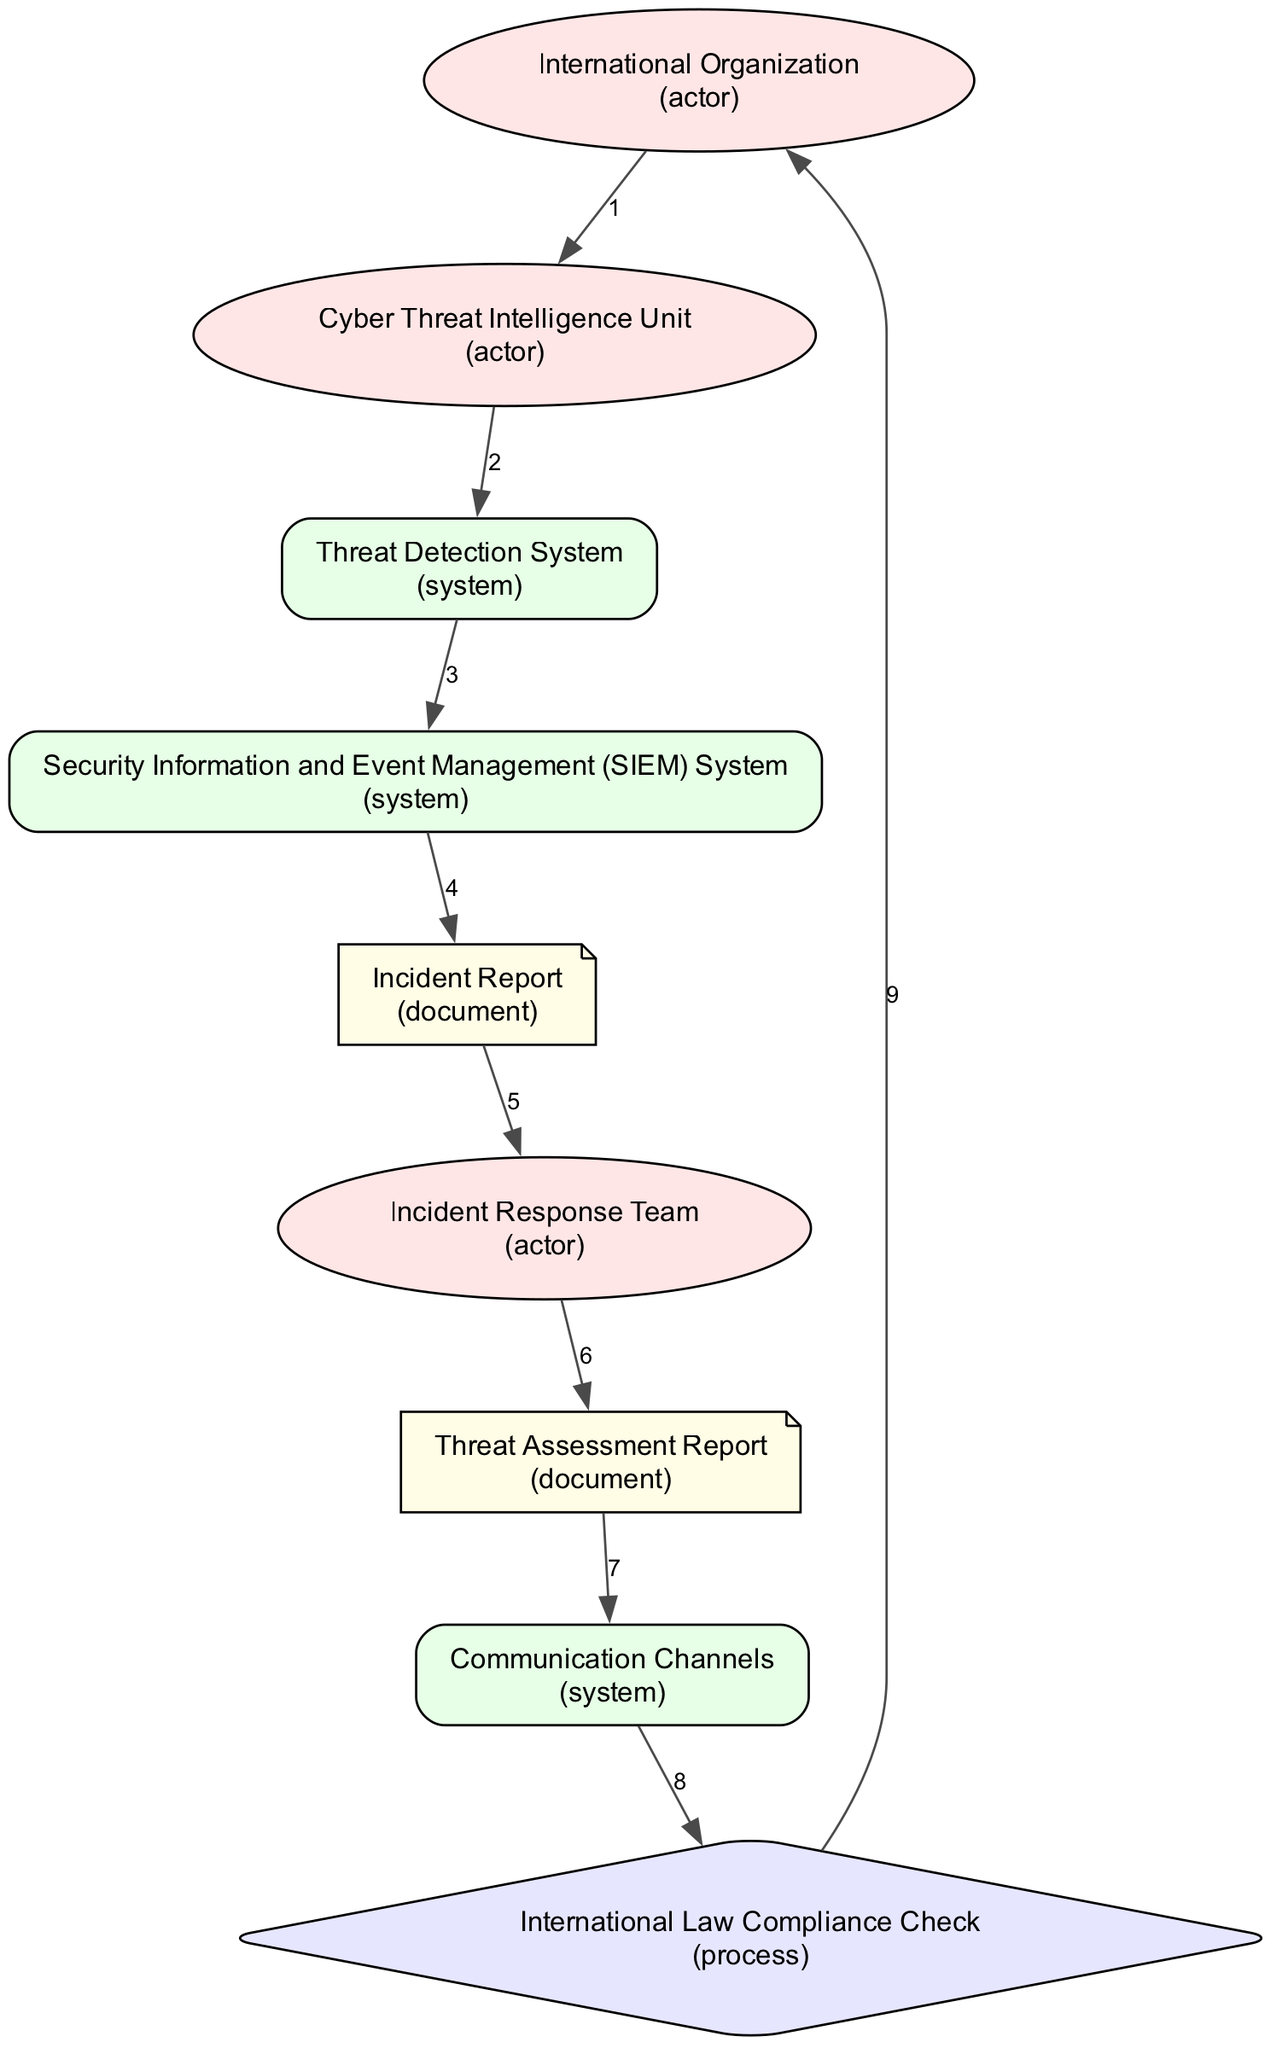What is the first actor in the sequence? The first actor listed in the sequence is "International Organization," which is the starting point for the response protocol in the diagram.
Answer: International Organization How many actors are involved in the diagram? There are three actors involved: "International Organization," "Cyber Threat Intelligence Unit," and "Incident Response Team." Counting only the actors gives us the total.
Answer: 3 What follows the "Threat Detection System" in the sequence? After "Threat Detection System," the next step is to interact with the "Security Information and Event Management (SIEM) System," which indicates the flow of operations in response to detected threats.
Answer: Security Information and Event Management (SIEM) System What is the purpose of the "Incident Report"? The "Incident Report" is the documentation created when a cyber incident is detected, serving to formally log the occurrence for further investigation and response handling.
Answer: Documentation of detected incidents What unique role does the "International Law Compliance Check" play in the sequence? The "International Law Compliance Check" ensures that all actions during the incident response comply with international legal standards, emphasizing the legal aspect of managing cyber incidents in the organization.
Answer: Ensuring compliance with international legal standards How many documents are in the sequence? The sequence includes two documents: the "Incident Report" and the "Threat Assessment Report," which are created as part of the cyber incident management processes.
Answer: 2 Which system collects and analyzes security data? The system that collects and analyzes security data is the "Security Information and Event Management (SIEM) System," which plays a critical role in integrating data from across the organization for analysis.
Answer: Security Information and Event Management (SIEM) System What does the "Threat Assessment Report" communicate? The "Threat Assessment Report" communicates the nature and scope of cyber threats as analyzed by the "Cyber Threat Intelligence Unit," providing essential insights for the Incident Response Team.
Answer: Nature and scope of threats What is the last entity involved in the sequence? The last entity in the sequence is the "International Organization," which signifies that the protocol returns to the oversight entity after the actions and communications during the incident have been addressed.
Answer: International Organization 